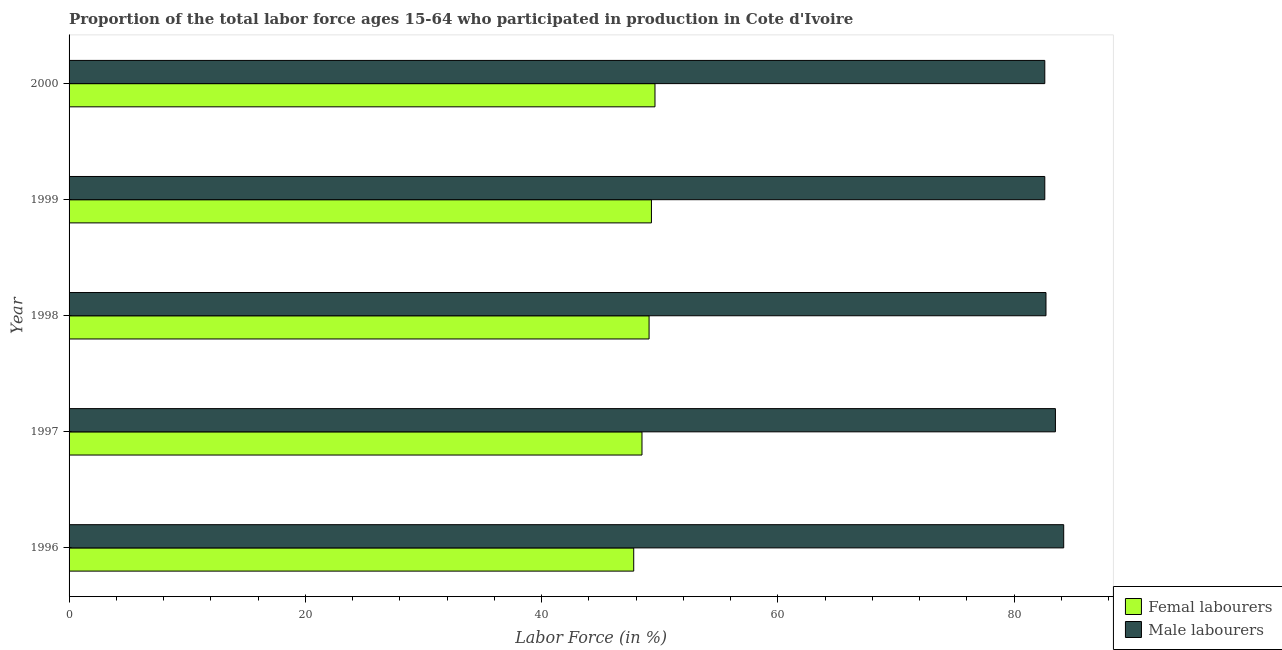Are the number of bars per tick equal to the number of legend labels?
Keep it short and to the point. Yes. Are the number of bars on each tick of the Y-axis equal?
Your response must be concise. Yes. How many bars are there on the 1st tick from the bottom?
Provide a short and direct response. 2. What is the label of the 1st group of bars from the top?
Provide a succinct answer. 2000. What is the percentage of female labor force in 1999?
Offer a terse response. 49.3. Across all years, what is the maximum percentage of male labour force?
Keep it short and to the point. 84.2. Across all years, what is the minimum percentage of female labor force?
Provide a short and direct response. 47.8. In which year was the percentage of male labour force minimum?
Offer a terse response. 1999. What is the total percentage of female labor force in the graph?
Provide a short and direct response. 244.3. What is the difference between the percentage of female labor force in 2000 and the percentage of male labour force in 1996?
Ensure brevity in your answer.  -34.6. What is the average percentage of male labour force per year?
Your response must be concise. 83.12. In the year 1998, what is the difference between the percentage of male labour force and percentage of female labor force?
Provide a short and direct response. 33.6. What is the ratio of the percentage of male labour force in 1996 to that in 1999?
Keep it short and to the point. 1.02. What is the difference between the highest and the second highest percentage of female labor force?
Keep it short and to the point. 0.3. What is the difference between the highest and the lowest percentage of female labor force?
Your answer should be compact. 1.8. In how many years, is the percentage of male labour force greater than the average percentage of male labour force taken over all years?
Ensure brevity in your answer.  2. What does the 2nd bar from the top in 1999 represents?
Provide a short and direct response. Femal labourers. What does the 2nd bar from the bottom in 1999 represents?
Give a very brief answer. Male labourers. Are all the bars in the graph horizontal?
Your answer should be very brief. Yes. Are the values on the major ticks of X-axis written in scientific E-notation?
Provide a short and direct response. No. Does the graph contain any zero values?
Offer a terse response. No. Does the graph contain grids?
Make the answer very short. No. Where does the legend appear in the graph?
Give a very brief answer. Bottom right. What is the title of the graph?
Ensure brevity in your answer.  Proportion of the total labor force ages 15-64 who participated in production in Cote d'Ivoire. Does "Start a business" appear as one of the legend labels in the graph?
Make the answer very short. No. What is the label or title of the X-axis?
Make the answer very short. Labor Force (in %). What is the label or title of the Y-axis?
Make the answer very short. Year. What is the Labor Force (in %) of Femal labourers in 1996?
Your answer should be very brief. 47.8. What is the Labor Force (in %) of Male labourers in 1996?
Make the answer very short. 84.2. What is the Labor Force (in %) of Femal labourers in 1997?
Make the answer very short. 48.5. What is the Labor Force (in %) in Male labourers in 1997?
Provide a succinct answer. 83.5. What is the Labor Force (in %) in Femal labourers in 1998?
Your answer should be very brief. 49.1. What is the Labor Force (in %) in Male labourers in 1998?
Ensure brevity in your answer.  82.7. What is the Labor Force (in %) of Femal labourers in 1999?
Keep it short and to the point. 49.3. What is the Labor Force (in %) of Male labourers in 1999?
Your answer should be very brief. 82.6. What is the Labor Force (in %) of Femal labourers in 2000?
Provide a succinct answer. 49.6. What is the Labor Force (in %) of Male labourers in 2000?
Give a very brief answer. 82.6. Across all years, what is the maximum Labor Force (in %) in Femal labourers?
Offer a terse response. 49.6. Across all years, what is the maximum Labor Force (in %) in Male labourers?
Provide a succinct answer. 84.2. Across all years, what is the minimum Labor Force (in %) in Femal labourers?
Make the answer very short. 47.8. Across all years, what is the minimum Labor Force (in %) of Male labourers?
Provide a succinct answer. 82.6. What is the total Labor Force (in %) of Femal labourers in the graph?
Ensure brevity in your answer.  244.3. What is the total Labor Force (in %) of Male labourers in the graph?
Provide a short and direct response. 415.6. What is the difference between the Labor Force (in %) of Femal labourers in 1996 and that in 1998?
Give a very brief answer. -1.3. What is the difference between the Labor Force (in %) in Male labourers in 1996 and that in 1998?
Keep it short and to the point. 1.5. What is the difference between the Labor Force (in %) in Femal labourers in 1996 and that in 1999?
Your response must be concise. -1.5. What is the difference between the Labor Force (in %) of Male labourers in 1996 and that in 1999?
Your response must be concise. 1.6. What is the difference between the Labor Force (in %) of Femal labourers in 1997 and that in 1998?
Provide a succinct answer. -0.6. What is the difference between the Labor Force (in %) in Femal labourers in 1997 and that in 1999?
Ensure brevity in your answer.  -0.8. What is the difference between the Labor Force (in %) in Femal labourers in 1997 and that in 2000?
Provide a succinct answer. -1.1. What is the difference between the Labor Force (in %) in Male labourers in 1997 and that in 2000?
Provide a short and direct response. 0.9. What is the difference between the Labor Force (in %) of Femal labourers in 1998 and that in 2000?
Your answer should be very brief. -0.5. What is the difference between the Labor Force (in %) of Male labourers in 1998 and that in 2000?
Offer a terse response. 0.1. What is the difference between the Labor Force (in %) of Femal labourers in 1999 and that in 2000?
Offer a very short reply. -0.3. What is the difference between the Labor Force (in %) in Femal labourers in 1996 and the Labor Force (in %) in Male labourers in 1997?
Make the answer very short. -35.7. What is the difference between the Labor Force (in %) in Femal labourers in 1996 and the Labor Force (in %) in Male labourers in 1998?
Your response must be concise. -34.9. What is the difference between the Labor Force (in %) of Femal labourers in 1996 and the Labor Force (in %) of Male labourers in 1999?
Keep it short and to the point. -34.8. What is the difference between the Labor Force (in %) of Femal labourers in 1996 and the Labor Force (in %) of Male labourers in 2000?
Give a very brief answer. -34.8. What is the difference between the Labor Force (in %) in Femal labourers in 1997 and the Labor Force (in %) in Male labourers in 1998?
Give a very brief answer. -34.2. What is the difference between the Labor Force (in %) in Femal labourers in 1997 and the Labor Force (in %) in Male labourers in 1999?
Your answer should be very brief. -34.1. What is the difference between the Labor Force (in %) of Femal labourers in 1997 and the Labor Force (in %) of Male labourers in 2000?
Your response must be concise. -34.1. What is the difference between the Labor Force (in %) in Femal labourers in 1998 and the Labor Force (in %) in Male labourers in 1999?
Offer a terse response. -33.5. What is the difference between the Labor Force (in %) in Femal labourers in 1998 and the Labor Force (in %) in Male labourers in 2000?
Give a very brief answer. -33.5. What is the difference between the Labor Force (in %) of Femal labourers in 1999 and the Labor Force (in %) of Male labourers in 2000?
Keep it short and to the point. -33.3. What is the average Labor Force (in %) of Femal labourers per year?
Give a very brief answer. 48.86. What is the average Labor Force (in %) in Male labourers per year?
Provide a succinct answer. 83.12. In the year 1996, what is the difference between the Labor Force (in %) in Femal labourers and Labor Force (in %) in Male labourers?
Offer a terse response. -36.4. In the year 1997, what is the difference between the Labor Force (in %) of Femal labourers and Labor Force (in %) of Male labourers?
Keep it short and to the point. -35. In the year 1998, what is the difference between the Labor Force (in %) of Femal labourers and Labor Force (in %) of Male labourers?
Make the answer very short. -33.6. In the year 1999, what is the difference between the Labor Force (in %) in Femal labourers and Labor Force (in %) in Male labourers?
Ensure brevity in your answer.  -33.3. In the year 2000, what is the difference between the Labor Force (in %) of Femal labourers and Labor Force (in %) of Male labourers?
Make the answer very short. -33. What is the ratio of the Labor Force (in %) of Femal labourers in 1996 to that in 1997?
Offer a terse response. 0.99. What is the ratio of the Labor Force (in %) in Male labourers in 1996 to that in 1997?
Your answer should be compact. 1.01. What is the ratio of the Labor Force (in %) of Femal labourers in 1996 to that in 1998?
Make the answer very short. 0.97. What is the ratio of the Labor Force (in %) of Male labourers in 1996 to that in 1998?
Your answer should be very brief. 1.02. What is the ratio of the Labor Force (in %) in Femal labourers in 1996 to that in 1999?
Your answer should be compact. 0.97. What is the ratio of the Labor Force (in %) of Male labourers in 1996 to that in 1999?
Offer a very short reply. 1.02. What is the ratio of the Labor Force (in %) in Femal labourers in 1996 to that in 2000?
Offer a terse response. 0.96. What is the ratio of the Labor Force (in %) of Male labourers in 1996 to that in 2000?
Keep it short and to the point. 1.02. What is the ratio of the Labor Force (in %) in Femal labourers in 1997 to that in 1998?
Ensure brevity in your answer.  0.99. What is the ratio of the Labor Force (in %) of Male labourers in 1997 to that in 1998?
Ensure brevity in your answer.  1.01. What is the ratio of the Labor Force (in %) in Femal labourers in 1997 to that in 1999?
Your answer should be very brief. 0.98. What is the ratio of the Labor Force (in %) in Male labourers in 1997 to that in 1999?
Provide a succinct answer. 1.01. What is the ratio of the Labor Force (in %) in Femal labourers in 1997 to that in 2000?
Ensure brevity in your answer.  0.98. What is the ratio of the Labor Force (in %) of Male labourers in 1997 to that in 2000?
Your response must be concise. 1.01. What is the ratio of the Labor Force (in %) in Femal labourers in 1998 to that in 2000?
Your answer should be compact. 0.99. What is the ratio of the Labor Force (in %) of Male labourers in 1998 to that in 2000?
Your response must be concise. 1. What is the ratio of the Labor Force (in %) in Male labourers in 1999 to that in 2000?
Keep it short and to the point. 1. What is the difference between the highest and the second highest Labor Force (in %) of Femal labourers?
Provide a succinct answer. 0.3. What is the difference between the highest and the lowest Labor Force (in %) in Femal labourers?
Keep it short and to the point. 1.8. 